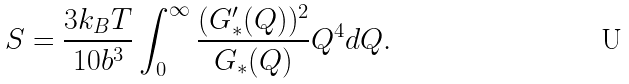Convert formula to latex. <formula><loc_0><loc_0><loc_500><loc_500>S = \frac { 3 k _ { B } T } { 1 0 b ^ { 3 } } \int _ { 0 } ^ { \infty } \frac { ( G _ { \ast } ^ { \prime } ( Q ) ) ^ { 2 } } { G _ { \ast } ( Q ) } Q ^ { 4 } d Q .</formula> 